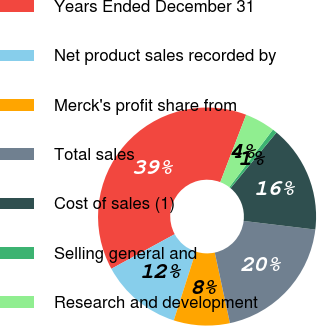Convert chart. <chart><loc_0><loc_0><loc_500><loc_500><pie_chart><fcel>Years Ended December 31<fcel>Net product sales recorded by<fcel>Merck's profit share from<fcel>Total sales<fcel>Cost of sales (1)<fcel>Selling general and<fcel>Research and development<nl><fcel>38.79%<fcel>12.11%<fcel>8.3%<fcel>19.73%<fcel>15.92%<fcel>0.67%<fcel>4.48%<nl></chart> 